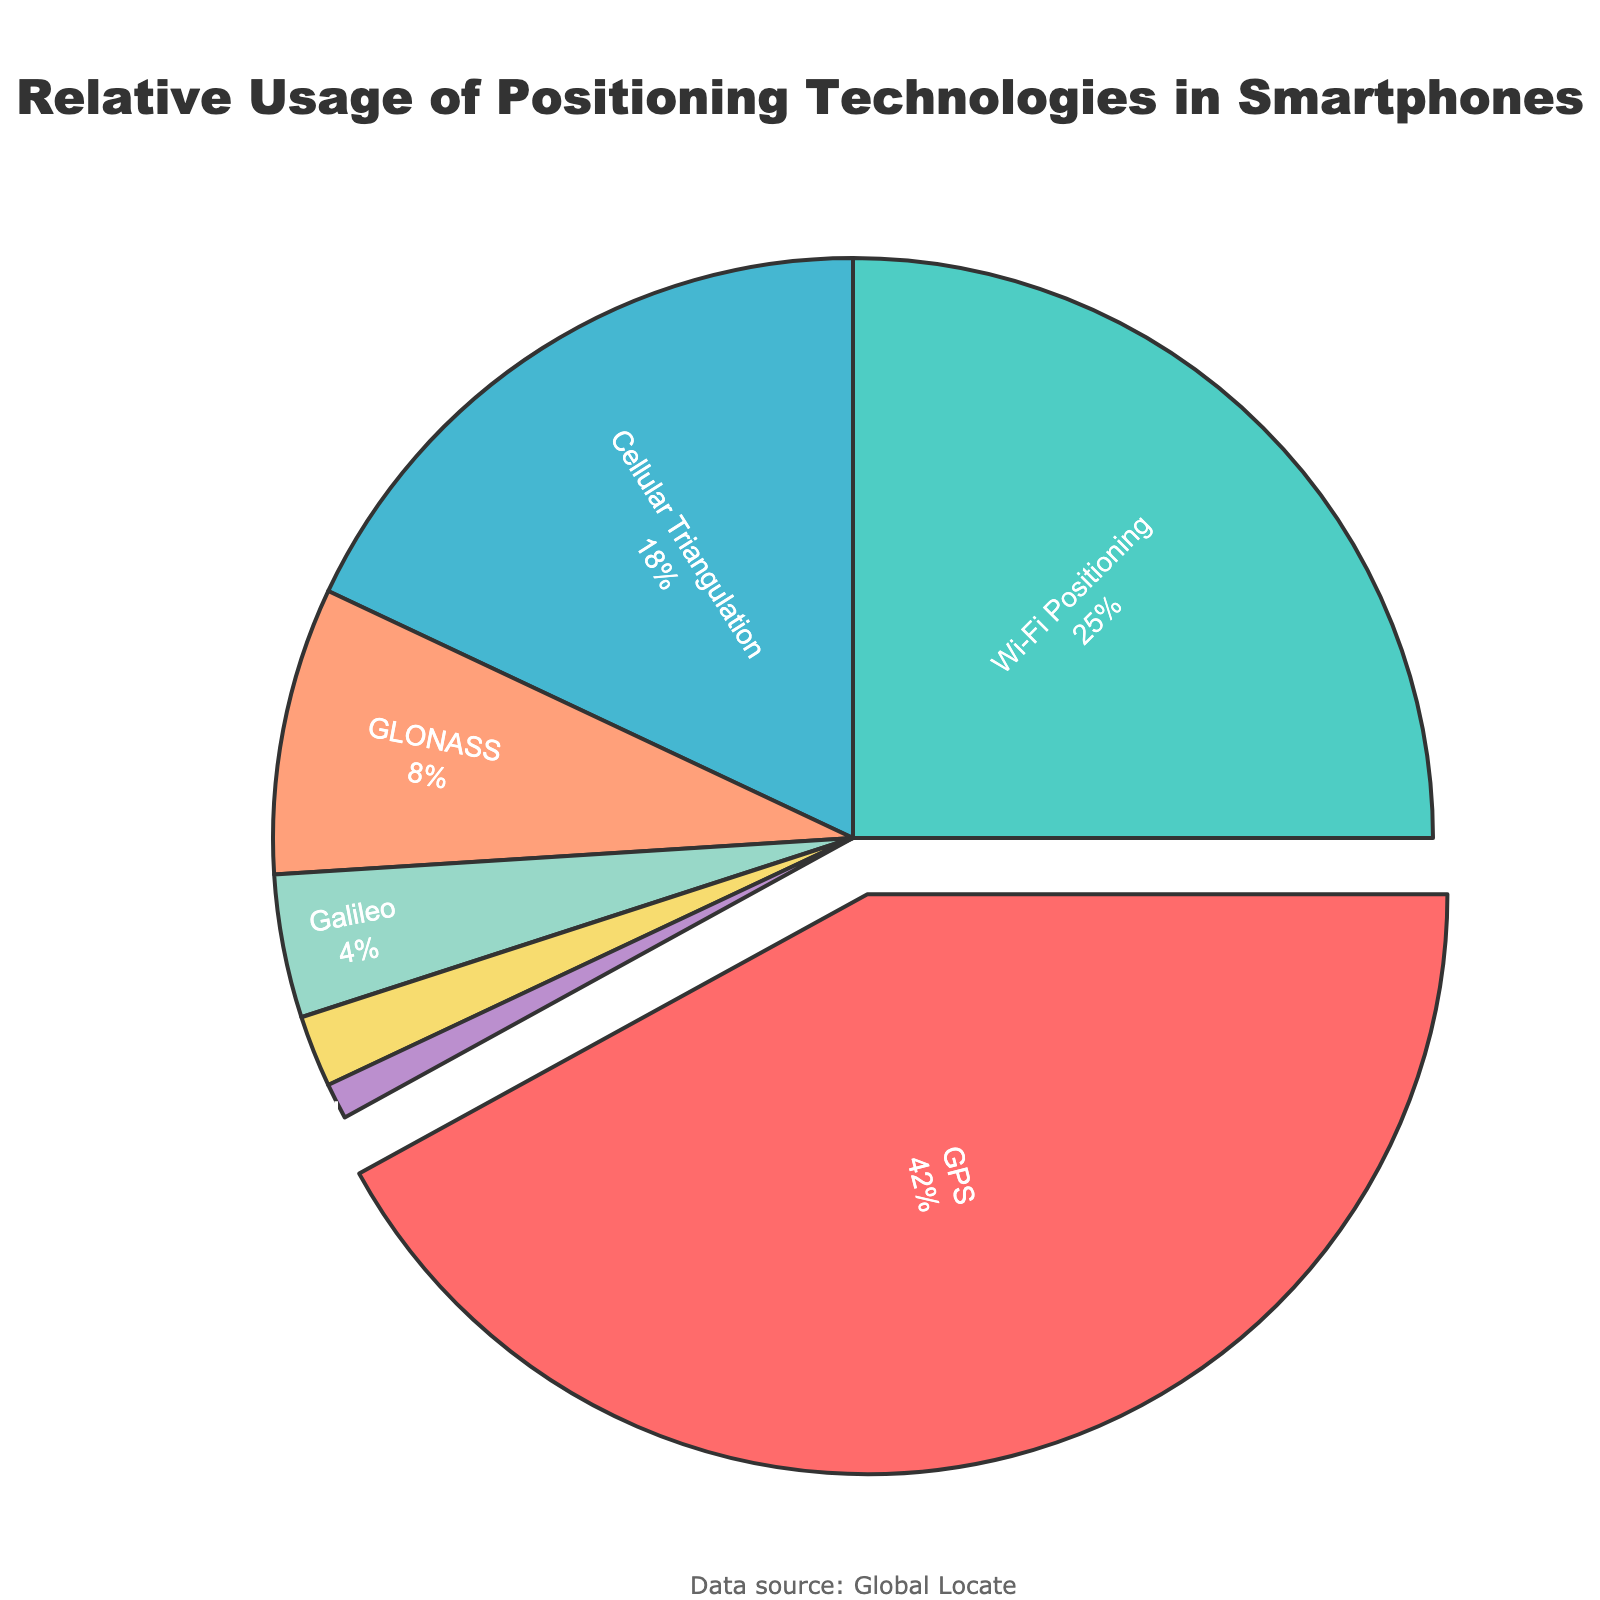What percentage of the usage is attributed to GPS? The segment labeled 'GPS' has 42% displayed next to it.
Answer: 42% Which positioning technology has the second-largest usage percentage? The second-largest slice of the pie chart is labeled 'Wi-Fi Positioning' with 25%.
Answer: Wi-Fi Positioning What's the combined percentage of usage for Cellular Triangulation and GLONASS? Cellular Triangulation has 18%, and GLONASS has 8%. Adding these percentages, 18% + 8% = 26%.
Answer: 26% How much larger is the GPS segment compared to the Galileo segment? The GPS segment is 42%, and the Galileo segment is 4%. The difference is 42% - 4% = 38%.
Answer: 38% Which technology is represented with the purple color? The purple color corresponds to the 'BeiDou' segment, which is labeled with 2%.
Answer: BeiDou What is the smallest segment on the pie chart? The smallest segment on the pie chart is 'Assisted GPS' with 1%.
Answer: Assisted GPS How many positioning technologies have a usage percentage of less than 10%? The segments with less than 10% are GLONASS (8%), Galileo (4%), BeiDou (2%), and Assisted GPS (1%). There are four such segments.
Answer: Four Is the sum of percentages for technologies other than GPS more or less than 60%? The sum of percentages for technologies other than GPS is 25% (Wi-Fi Positioning) + 18% (Cellular Triangulation) + 8% (GLONASS) + 4% (Galileo) + 2% (BeiDou) + 1% (Assisted GPS) = 58%, which is less than 60%.
Answer: Less Which three technologies combined have the highest overall usage percentage? The three largest segments are GPS (42%), Wi-Fi Positioning (25%), and Cellular Triangulation (18%). Adding these, 42% + 25% + 18% = 85%.
Answer: GPS, Wi-Fi Positioning, Cellular Triangulation What is the difference in usage percentage between Wi-Fi Positioning and Cellular Triangulation? Wi-Fi Positioning has 25%, and Cellular Triangulation has 18%. The difference is 25% - 18% = 7%.
Answer: 7% 